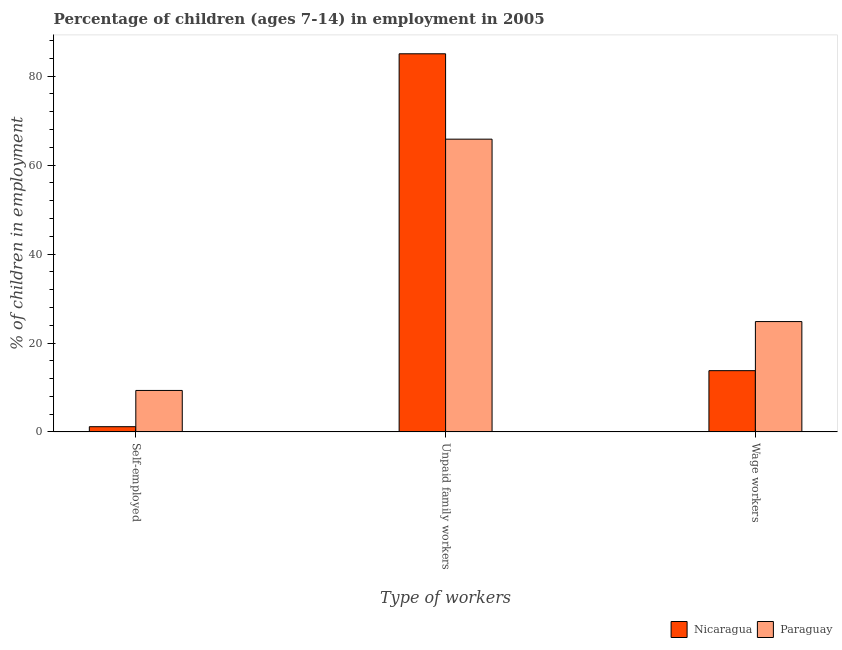How many groups of bars are there?
Offer a terse response. 3. Are the number of bars on each tick of the X-axis equal?
Provide a short and direct response. Yes. What is the label of the 3rd group of bars from the left?
Ensure brevity in your answer.  Wage workers. What is the percentage of self employed children in Nicaragua?
Your answer should be very brief. 1.18. Across all countries, what is the maximum percentage of children employed as wage workers?
Keep it short and to the point. 24.82. Across all countries, what is the minimum percentage of self employed children?
Your response must be concise. 1.18. In which country was the percentage of children employed as wage workers maximum?
Your response must be concise. Paraguay. In which country was the percentage of children employed as unpaid family workers minimum?
Offer a terse response. Paraguay. What is the total percentage of children employed as unpaid family workers in the graph?
Your answer should be compact. 150.88. What is the difference between the percentage of children employed as wage workers in Nicaragua and that in Paraguay?
Provide a short and direct response. -11.04. What is the difference between the percentage of children employed as unpaid family workers in Nicaragua and the percentage of self employed children in Paraguay?
Provide a succinct answer. 75.71. What is the average percentage of children employed as unpaid family workers per country?
Ensure brevity in your answer.  75.44. What is the difference between the percentage of children employed as unpaid family workers and percentage of self employed children in Nicaragua?
Offer a very short reply. 83.86. What is the ratio of the percentage of children employed as wage workers in Paraguay to that in Nicaragua?
Make the answer very short. 1.8. Is the percentage of self employed children in Nicaragua less than that in Paraguay?
Make the answer very short. Yes. Is the difference between the percentage of children employed as wage workers in Nicaragua and Paraguay greater than the difference between the percentage of self employed children in Nicaragua and Paraguay?
Offer a terse response. No. What is the difference between the highest and the second highest percentage of self employed children?
Ensure brevity in your answer.  8.15. What is the difference between the highest and the lowest percentage of children employed as unpaid family workers?
Offer a very short reply. 19.2. In how many countries, is the percentage of children employed as unpaid family workers greater than the average percentage of children employed as unpaid family workers taken over all countries?
Offer a terse response. 1. What does the 2nd bar from the left in Unpaid family workers represents?
Your answer should be compact. Paraguay. What does the 1st bar from the right in Wage workers represents?
Give a very brief answer. Paraguay. Is it the case that in every country, the sum of the percentage of self employed children and percentage of children employed as unpaid family workers is greater than the percentage of children employed as wage workers?
Your answer should be compact. Yes. How many bars are there?
Offer a terse response. 6. What is the difference between two consecutive major ticks on the Y-axis?
Keep it short and to the point. 20. Does the graph contain grids?
Ensure brevity in your answer.  No. What is the title of the graph?
Give a very brief answer. Percentage of children (ages 7-14) in employment in 2005. Does "Portugal" appear as one of the legend labels in the graph?
Offer a terse response. No. What is the label or title of the X-axis?
Give a very brief answer. Type of workers. What is the label or title of the Y-axis?
Ensure brevity in your answer.  % of children in employment. What is the % of children in employment of Nicaragua in Self-employed?
Your answer should be compact. 1.18. What is the % of children in employment in Paraguay in Self-employed?
Your answer should be compact. 9.33. What is the % of children in employment of Nicaragua in Unpaid family workers?
Give a very brief answer. 85.04. What is the % of children in employment in Paraguay in Unpaid family workers?
Provide a short and direct response. 65.84. What is the % of children in employment in Nicaragua in Wage workers?
Ensure brevity in your answer.  13.78. What is the % of children in employment of Paraguay in Wage workers?
Your response must be concise. 24.82. Across all Type of workers, what is the maximum % of children in employment in Nicaragua?
Provide a succinct answer. 85.04. Across all Type of workers, what is the maximum % of children in employment of Paraguay?
Your answer should be compact. 65.84. Across all Type of workers, what is the minimum % of children in employment in Nicaragua?
Offer a very short reply. 1.18. Across all Type of workers, what is the minimum % of children in employment in Paraguay?
Make the answer very short. 9.33. What is the total % of children in employment of Paraguay in the graph?
Your response must be concise. 99.99. What is the difference between the % of children in employment in Nicaragua in Self-employed and that in Unpaid family workers?
Keep it short and to the point. -83.86. What is the difference between the % of children in employment in Paraguay in Self-employed and that in Unpaid family workers?
Make the answer very short. -56.51. What is the difference between the % of children in employment in Nicaragua in Self-employed and that in Wage workers?
Ensure brevity in your answer.  -12.6. What is the difference between the % of children in employment in Paraguay in Self-employed and that in Wage workers?
Keep it short and to the point. -15.49. What is the difference between the % of children in employment of Nicaragua in Unpaid family workers and that in Wage workers?
Keep it short and to the point. 71.26. What is the difference between the % of children in employment of Paraguay in Unpaid family workers and that in Wage workers?
Your response must be concise. 41.02. What is the difference between the % of children in employment of Nicaragua in Self-employed and the % of children in employment of Paraguay in Unpaid family workers?
Keep it short and to the point. -64.66. What is the difference between the % of children in employment in Nicaragua in Self-employed and the % of children in employment in Paraguay in Wage workers?
Make the answer very short. -23.64. What is the difference between the % of children in employment in Nicaragua in Unpaid family workers and the % of children in employment in Paraguay in Wage workers?
Your answer should be very brief. 60.22. What is the average % of children in employment in Nicaragua per Type of workers?
Provide a succinct answer. 33.33. What is the average % of children in employment in Paraguay per Type of workers?
Offer a terse response. 33.33. What is the difference between the % of children in employment in Nicaragua and % of children in employment in Paraguay in Self-employed?
Offer a very short reply. -8.15. What is the difference between the % of children in employment in Nicaragua and % of children in employment in Paraguay in Wage workers?
Your answer should be very brief. -11.04. What is the ratio of the % of children in employment of Nicaragua in Self-employed to that in Unpaid family workers?
Give a very brief answer. 0.01. What is the ratio of the % of children in employment of Paraguay in Self-employed to that in Unpaid family workers?
Provide a short and direct response. 0.14. What is the ratio of the % of children in employment of Nicaragua in Self-employed to that in Wage workers?
Provide a short and direct response. 0.09. What is the ratio of the % of children in employment of Paraguay in Self-employed to that in Wage workers?
Your answer should be very brief. 0.38. What is the ratio of the % of children in employment in Nicaragua in Unpaid family workers to that in Wage workers?
Make the answer very short. 6.17. What is the ratio of the % of children in employment of Paraguay in Unpaid family workers to that in Wage workers?
Offer a terse response. 2.65. What is the difference between the highest and the second highest % of children in employment of Nicaragua?
Ensure brevity in your answer.  71.26. What is the difference between the highest and the second highest % of children in employment in Paraguay?
Keep it short and to the point. 41.02. What is the difference between the highest and the lowest % of children in employment in Nicaragua?
Your answer should be very brief. 83.86. What is the difference between the highest and the lowest % of children in employment in Paraguay?
Provide a succinct answer. 56.51. 